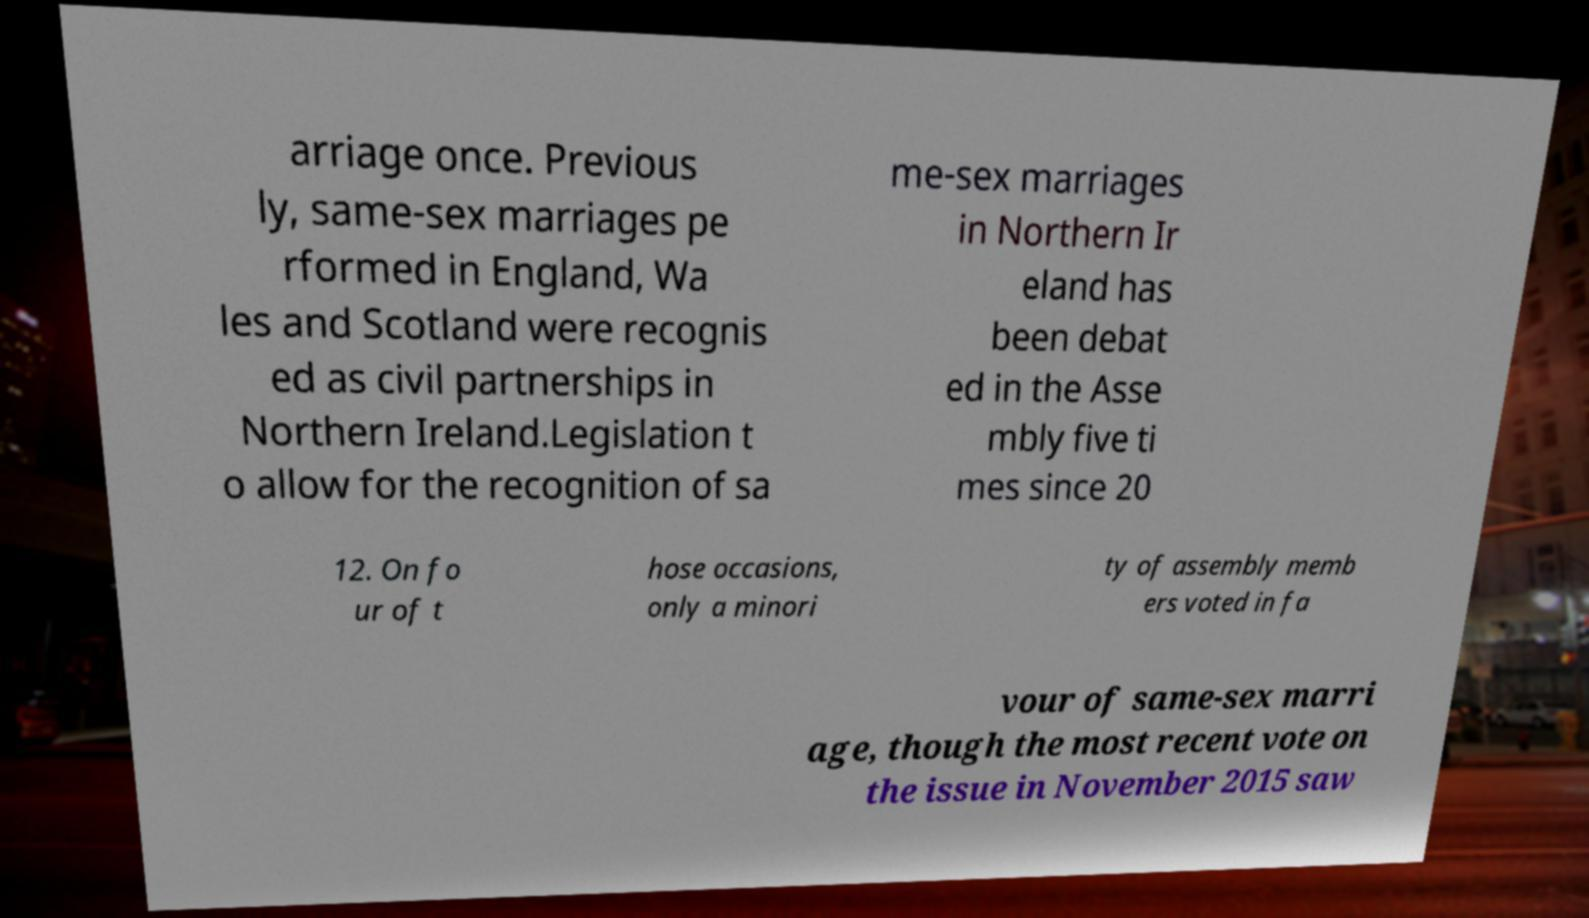Could you assist in decoding the text presented in this image and type it out clearly? arriage once. Previous ly, same-sex marriages pe rformed in England, Wa les and Scotland were recognis ed as civil partnerships in Northern Ireland.Legislation t o allow for the recognition of sa me-sex marriages in Northern Ir eland has been debat ed in the Asse mbly five ti mes since 20 12. On fo ur of t hose occasions, only a minori ty of assembly memb ers voted in fa vour of same-sex marri age, though the most recent vote on the issue in November 2015 saw 